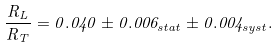Convert formula to latex. <formula><loc_0><loc_0><loc_500><loc_500>\frac { R _ { L } } { R _ { T } } = 0 . 0 4 0 \pm 0 . 0 0 6 _ { s t a t } \pm 0 . 0 0 4 _ { s y s t } .</formula> 